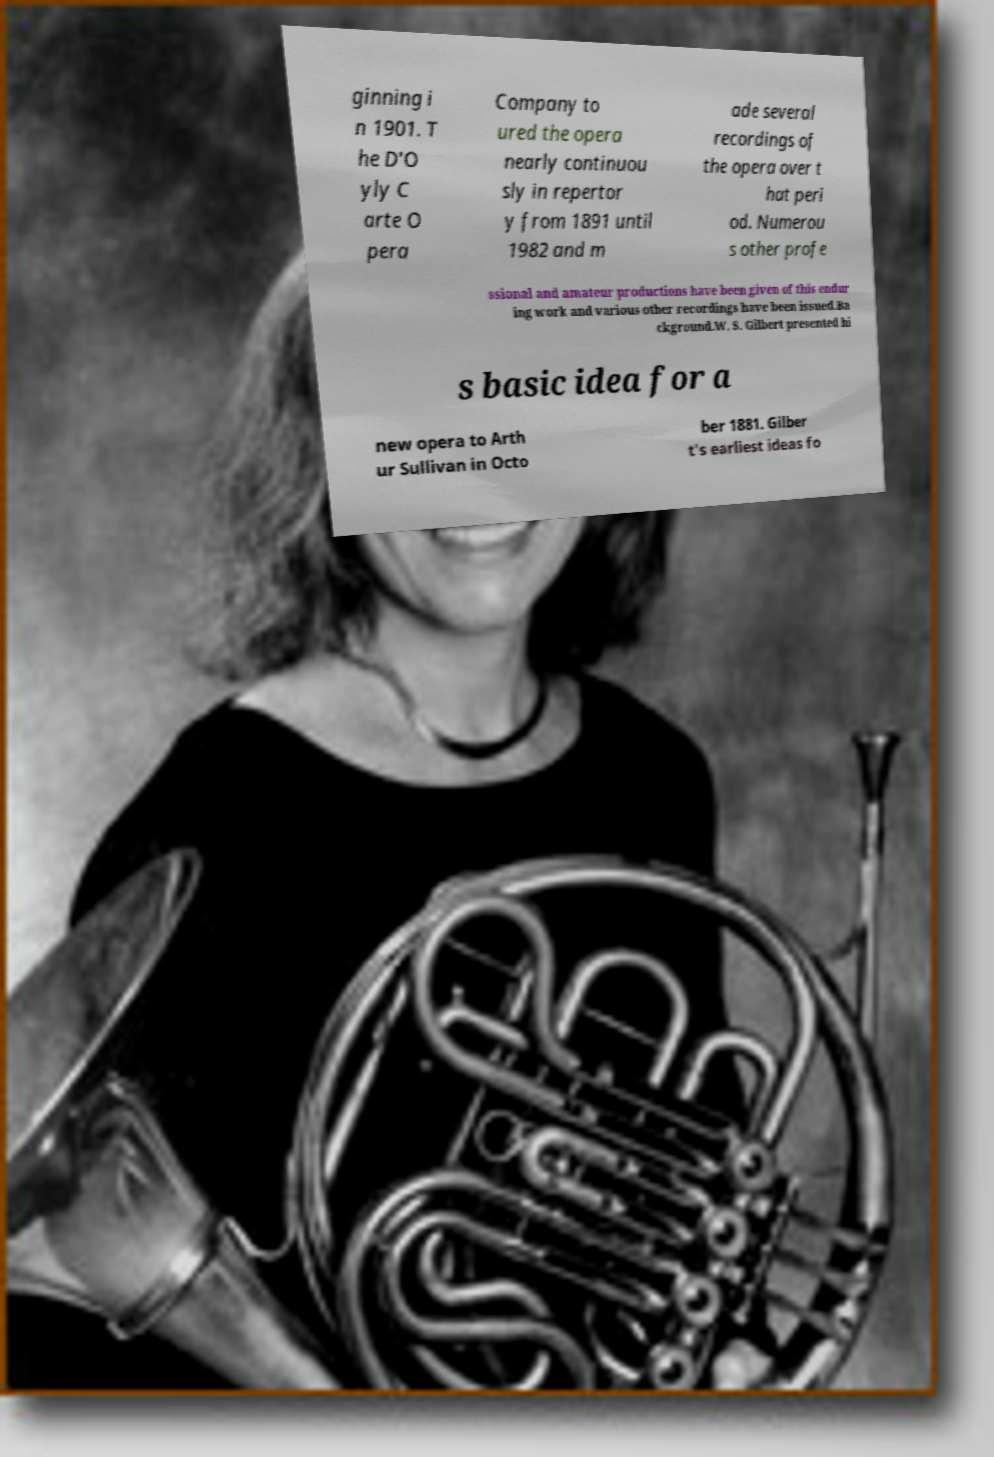For documentation purposes, I need the text within this image transcribed. Could you provide that? ginning i n 1901. T he D'O yly C arte O pera Company to ured the opera nearly continuou sly in repertor y from 1891 until 1982 and m ade several recordings of the opera over t hat peri od. Numerou s other profe ssional and amateur productions have been given of this endur ing work and various other recordings have been issued.Ba ckground.W. S. Gilbert presented hi s basic idea for a new opera to Arth ur Sullivan in Octo ber 1881. Gilber t's earliest ideas fo 